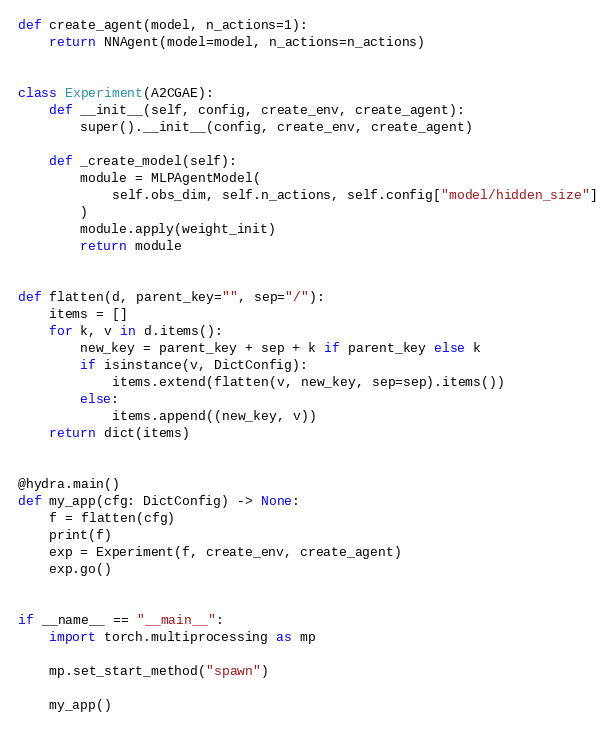<code> <loc_0><loc_0><loc_500><loc_500><_Python_>

def create_agent(model, n_actions=1):
    return NNAgent(model=model, n_actions=n_actions)


class Experiment(A2CGAE):
    def __init__(self, config, create_env, create_agent):
        super().__init__(config, create_env, create_agent)

    def _create_model(self):
        module = MLPAgentModel(
            self.obs_dim, self.n_actions, self.config["model/hidden_size"]
        )
        module.apply(weight_init)
        return module


def flatten(d, parent_key="", sep="/"):
    items = []
    for k, v in d.items():
        new_key = parent_key + sep + k if parent_key else k
        if isinstance(v, DictConfig):
            items.extend(flatten(v, new_key, sep=sep).items())
        else:
            items.append((new_key, v))
    return dict(items)


@hydra.main()
def my_app(cfg: DictConfig) -> None:
    f = flatten(cfg)
    print(f)
    exp = Experiment(f, create_env, create_agent)
    exp.go()


if __name__ == "__main__":
    import torch.multiprocessing as mp

    mp.set_start_method("spawn")

    my_app()
</code> 